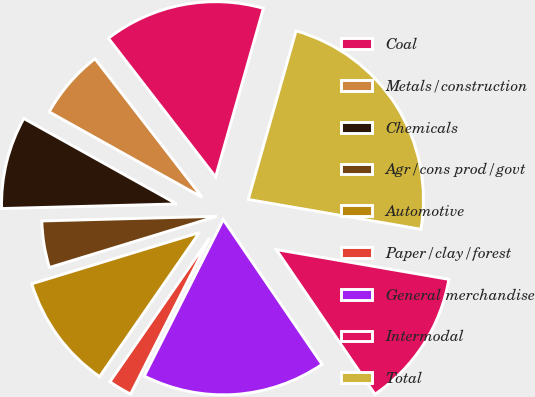Convert chart to OTSL. <chart><loc_0><loc_0><loc_500><loc_500><pie_chart><fcel>Coal<fcel>Metals/construction<fcel>Chemicals<fcel>Agr/cons prod/govt<fcel>Automotive<fcel>Paper/clay/forest<fcel>General merchandise<fcel>Intermodal<fcel>Total<nl><fcel>14.87%<fcel>6.42%<fcel>8.53%<fcel>4.3%<fcel>10.64%<fcel>2.19%<fcel>16.98%<fcel>12.75%<fcel>23.32%<nl></chart> 